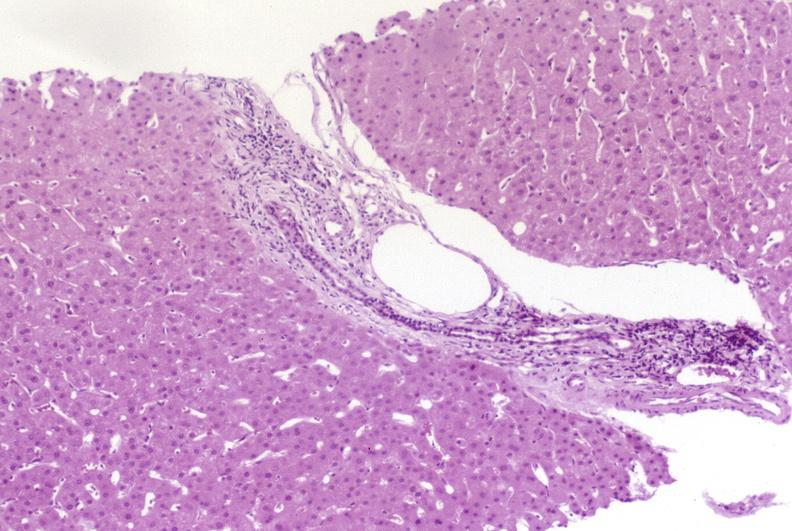s heel ulcer present?
Answer the question using a single word or phrase. No 